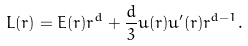<formula> <loc_0><loc_0><loc_500><loc_500>L ( r ) = E ( r ) r ^ { d } + \frac { d } { 3 } u ( r ) u ^ { \prime } ( r ) r ^ { d - 1 } .</formula> 